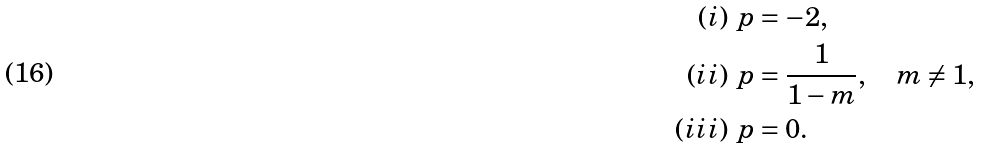<formula> <loc_0><loc_0><loc_500><loc_500>( i ) \ & p = - 2 , \\ ( i i ) \ & p = \frac { 1 } { 1 - m } , \quad m \ne 1 , \\ ( i i i ) \ & p = 0 .</formula> 